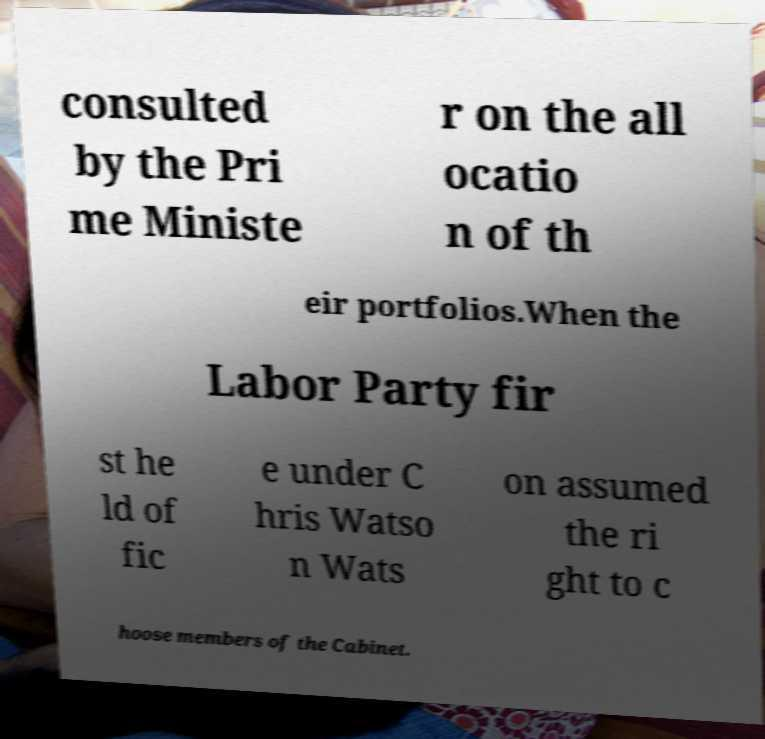Please read and relay the text visible in this image. What does it say? consulted by the Pri me Ministe r on the all ocatio n of th eir portfolios.When the Labor Party fir st he ld of fic e under C hris Watso n Wats on assumed the ri ght to c hoose members of the Cabinet. 